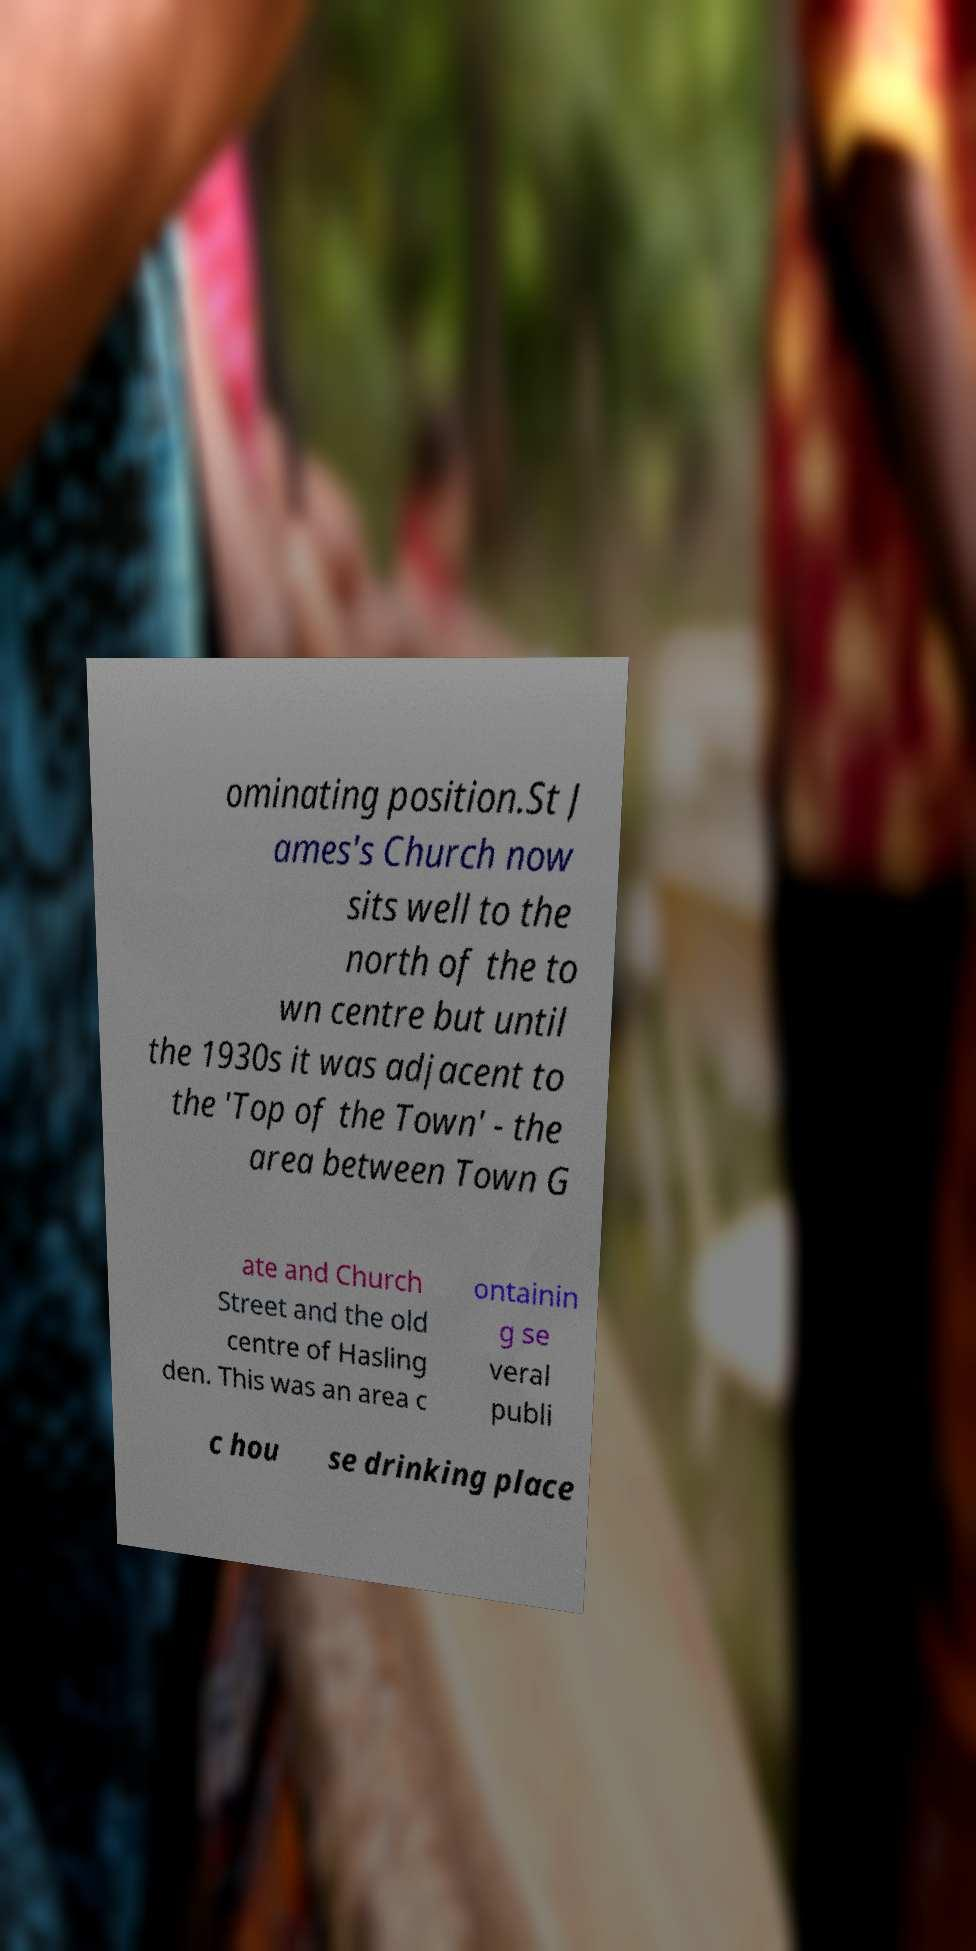Could you assist in decoding the text presented in this image and type it out clearly? ominating position.St J ames's Church now sits well to the north of the to wn centre but until the 1930s it was adjacent to the 'Top of the Town' - the area between Town G ate and Church Street and the old centre of Hasling den. This was an area c ontainin g se veral publi c hou se drinking place 